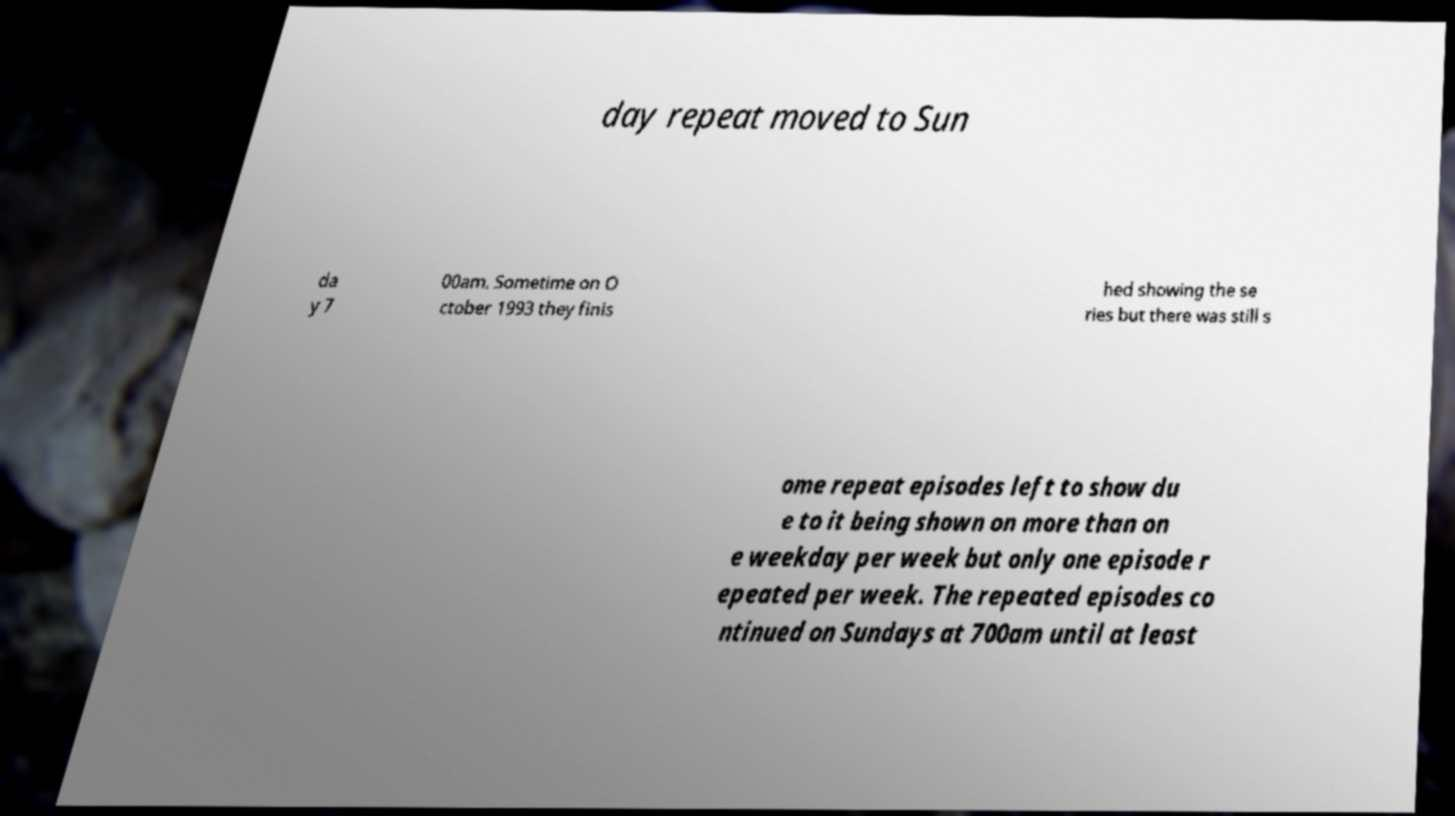There's text embedded in this image that I need extracted. Can you transcribe it verbatim? day repeat moved to Sun da y 7 00am. Sometime on O ctober 1993 they finis hed showing the se ries but there was still s ome repeat episodes left to show du e to it being shown on more than on e weekday per week but only one episode r epeated per week. The repeated episodes co ntinued on Sundays at 700am until at least 